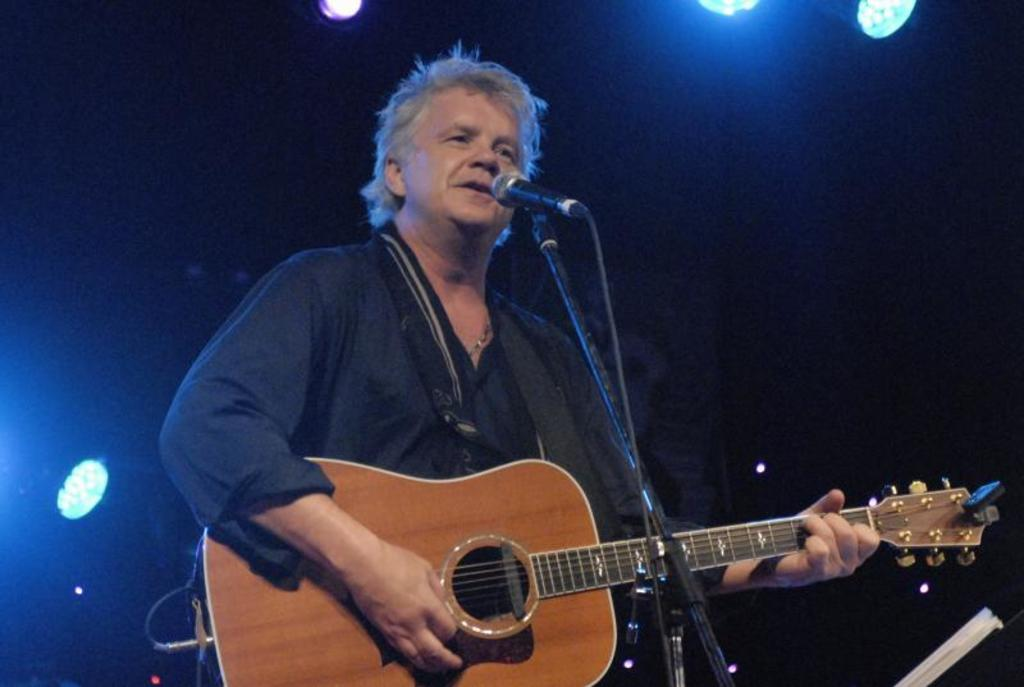What is the man in the center of the image doing? The man is standing in the center of the image and holding a guitar. What object is in front of the man? There is a microphone in front of the man. What can be seen in the background of the image? There is a wall and lights in the background of the image. What type of root can be seen growing from the guitar in the image? There is no root growing from the guitar in the image; it is a musical instrument. 